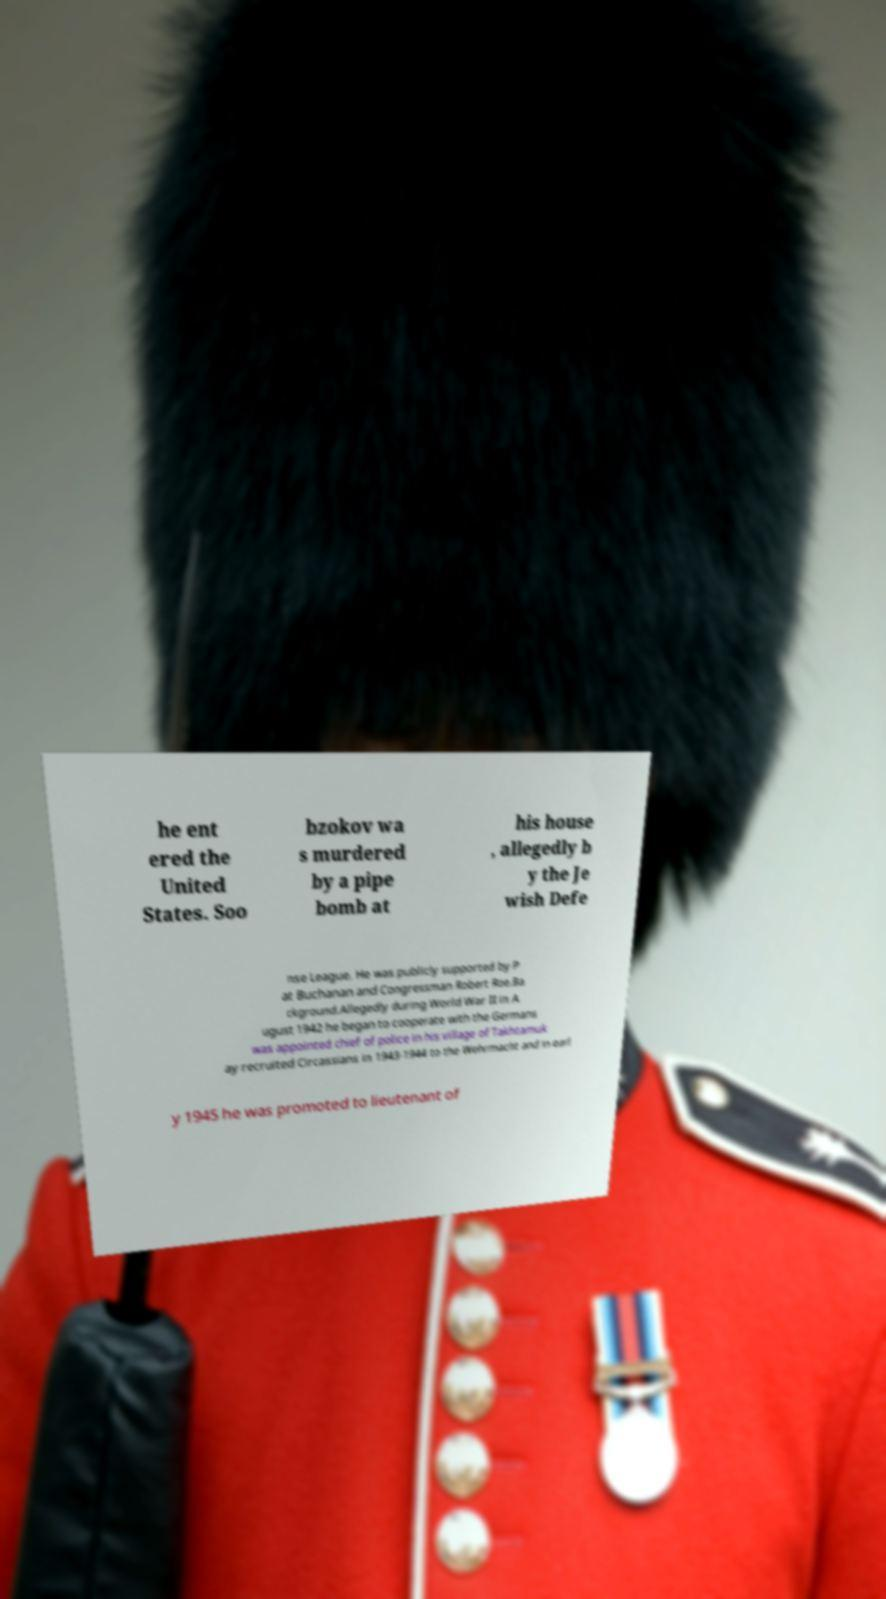Can you accurately transcribe the text from the provided image for me? he ent ered the United States. Soo bzokov wa s murdered by a pipe bomb at his house , allegedly b y the Je wish Defe nse League. He was publicly supported by P at Buchanan and Congressman Robert Roe.Ba ckground.Allegedly during World War II in A ugust 1942 he began to cooperate with the Germans was appointed chief of police in his village of Takhtamuk ay recruited Circassians in 1943-1944 to the Wehrmacht and in earl y 1945 he was promoted to lieutenant of 